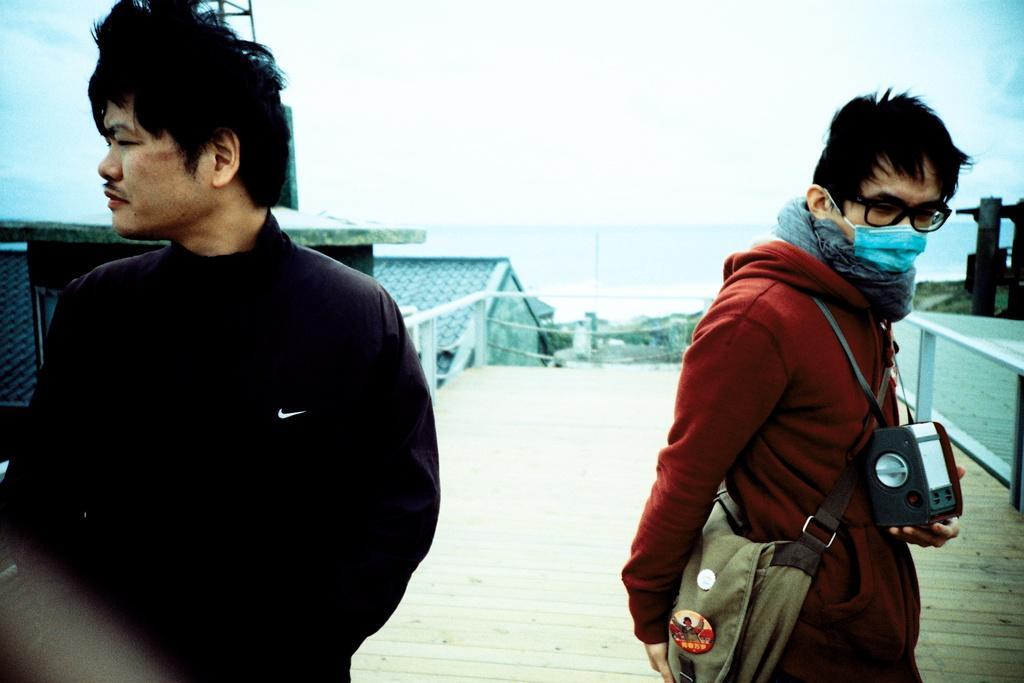Please provide a concise description of this image. In the center of the image we can see two persons are standing. And the left side person is holding some objects and he is wearing glasses and a disposable face mask. In the background, we can see the sky, buildings, fences and a few other objects. 